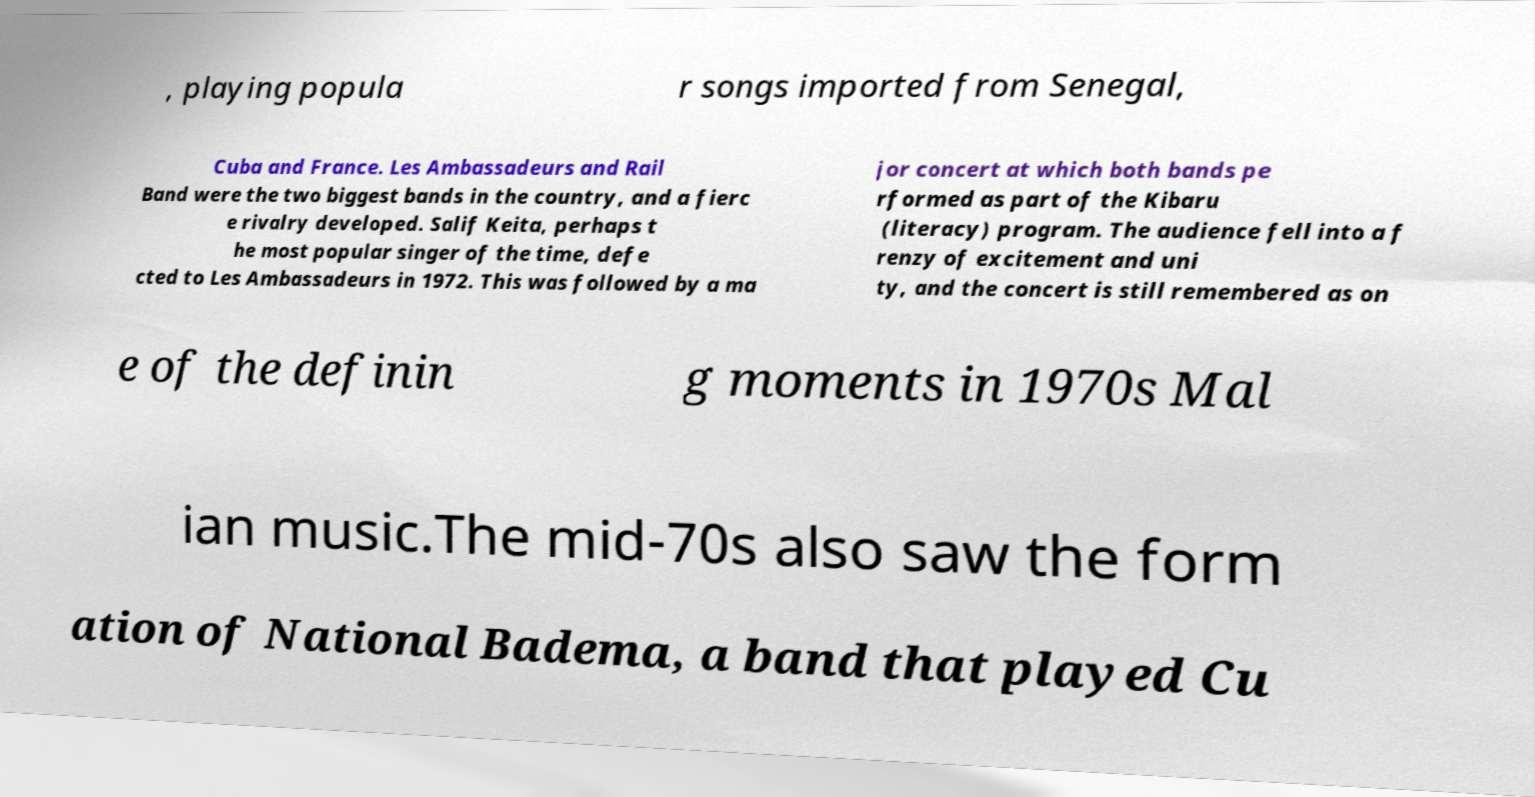Can you read and provide the text displayed in the image?This photo seems to have some interesting text. Can you extract and type it out for me? , playing popula r songs imported from Senegal, Cuba and France. Les Ambassadeurs and Rail Band were the two biggest bands in the country, and a fierc e rivalry developed. Salif Keita, perhaps t he most popular singer of the time, defe cted to Les Ambassadeurs in 1972. This was followed by a ma jor concert at which both bands pe rformed as part of the Kibaru (literacy) program. The audience fell into a f renzy of excitement and uni ty, and the concert is still remembered as on e of the definin g moments in 1970s Mal ian music.The mid-70s also saw the form ation of National Badema, a band that played Cu 